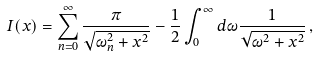<formula> <loc_0><loc_0><loc_500><loc_500>I ( x ) = \sum ^ { \infty } _ { n = 0 } \frac { \pi } { \sqrt { \omega _ { n } ^ { 2 } + x ^ { 2 } } } - \frac { 1 } { 2 } \int ^ { \infty } _ { 0 } d \omega \frac { 1 } { \sqrt { \omega ^ { 2 } + x ^ { 2 } } } \, ,</formula> 